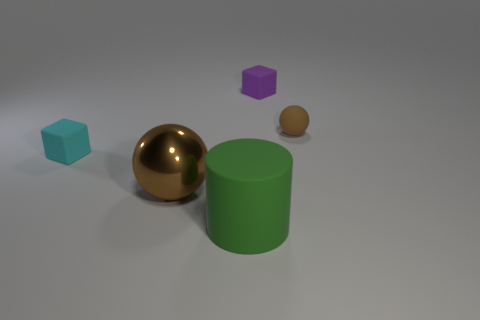Imagine these objects were part of a toy set. Can you create a story using them? In a whimsical world of shapes, the green cylinder serves as the towering guardian of the realm, standing tall and proud. The gold sphere, with its shimmering, lustrous surface, is the Sun Orb, a treasure that provides light and warmth to the land. The smaller brown sphere is the Seed of Life, a magical core that can sprout into any object when planted. The vivacious purple cube is the Wisdom Box, containing ancient knowledge, while the teal cube is known as the Ice Crystal, with powers to cool and refresh the environment. Together, they maintain harmony in the Land of Geometric Wonders. 